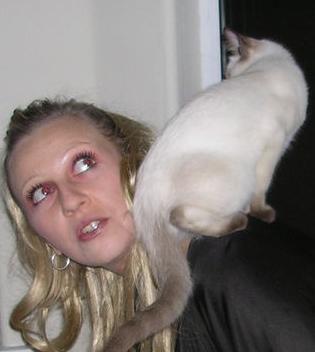Is the cat jumping?
Write a very short answer. No. What type of animal is this?
Give a very brief answer. Cat. Is the cat looking at the camera?
Write a very short answer. No. On what body part is this cat sitting?
Write a very short answer. Shoulder. 